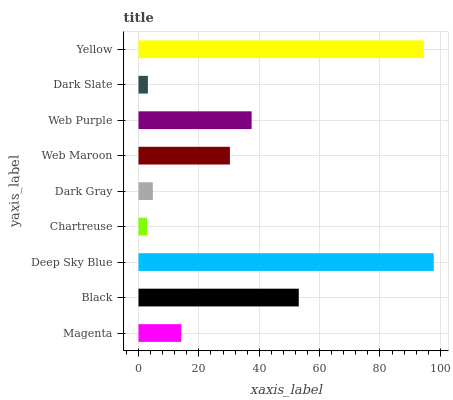Is Chartreuse the minimum?
Answer yes or no. Yes. Is Deep Sky Blue the maximum?
Answer yes or no. Yes. Is Black the minimum?
Answer yes or no. No. Is Black the maximum?
Answer yes or no. No. Is Black greater than Magenta?
Answer yes or no. Yes. Is Magenta less than Black?
Answer yes or no. Yes. Is Magenta greater than Black?
Answer yes or no. No. Is Black less than Magenta?
Answer yes or no. No. Is Web Maroon the high median?
Answer yes or no. Yes. Is Web Maroon the low median?
Answer yes or no. Yes. Is Black the high median?
Answer yes or no. No. Is Dark Slate the low median?
Answer yes or no. No. 